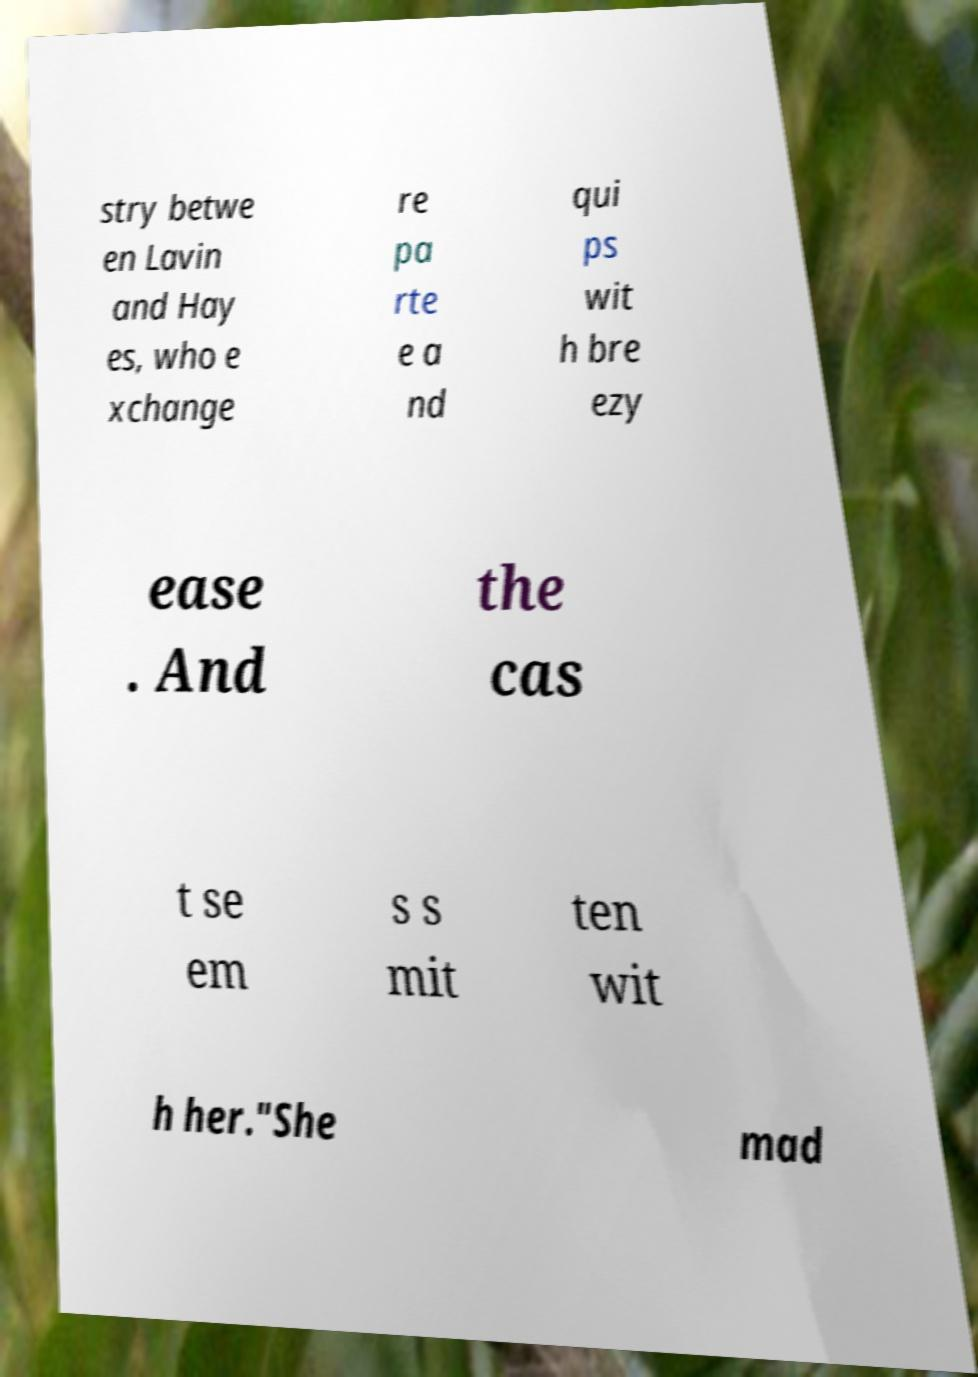What messages or text are displayed in this image? I need them in a readable, typed format. stry betwe en Lavin and Hay es, who e xchange re pa rte e a nd qui ps wit h bre ezy ease . And the cas t se em s s mit ten wit h her."She mad 